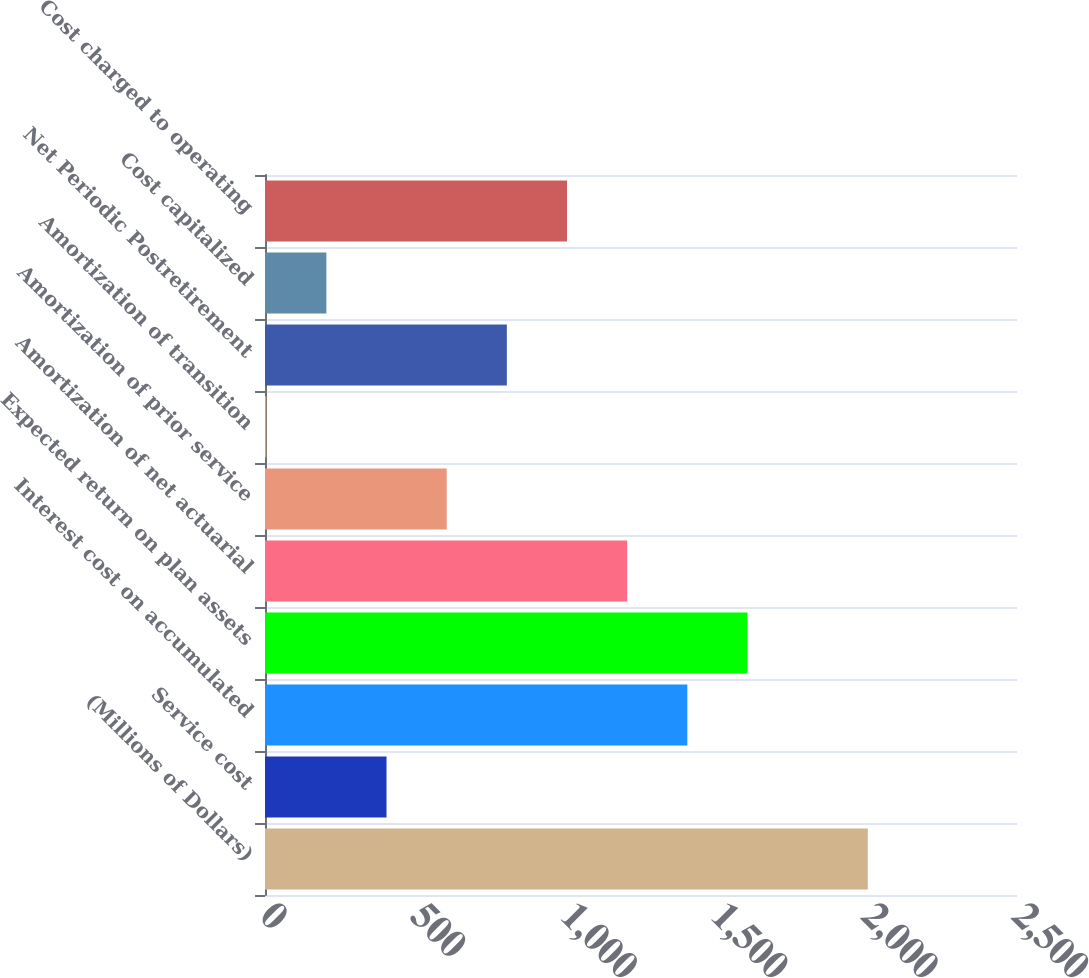<chart> <loc_0><loc_0><loc_500><loc_500><bar_chart><fcel>(Millions of Dollars)<fcel>Service cost<fcel>Interest cost on accumulated<fcel>Expected return on plan assets<fcel>Amortization of net actuarial<fcel>Amortization of prior service<fcel>Amortization of transition<fcel>Net Periodic Postretirement<fcel>Cost capitalized<fcel>Cost charged to operating<nl><fcel>2004<fcel>404<fcel>1404<fcel>1604<fcel>1204<fcel>604<fcel>4<fcel>804<fcel>204<fcel>1004<nl></chart> 